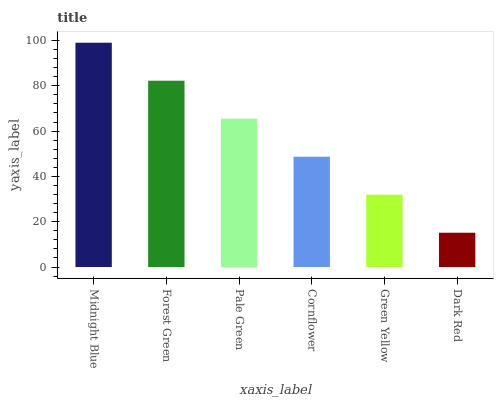Is Dark Red the minimum?
Answer yes or no. Yes. Is Midnight Blue the maximum?
Answer yes or no. Yes. Is Forest Green the minimum?
Answer yes or no. No. Is Forest Green the maximum?
Answer yes or no. No. Is Midnight Blue greater than Forest Green?
Answer yes or no. Yes. Is Forest Green less than Midnight Blue?
Answer yes or no. Yes. Is Forest Green greater than Midnight Blue?
Answer yes or no. No. Is Midnight Blue less than Forest Green?
Answer yes or no. No. Is Pale Green the high median?
Answer yes or no. Yes. Is Cornflower the low median?
Answer yes or no. Yes. Is Midnight Blue the high median?
Answer yes or no. No. Is Dark Red the low median?
Answer yes or no. No. 